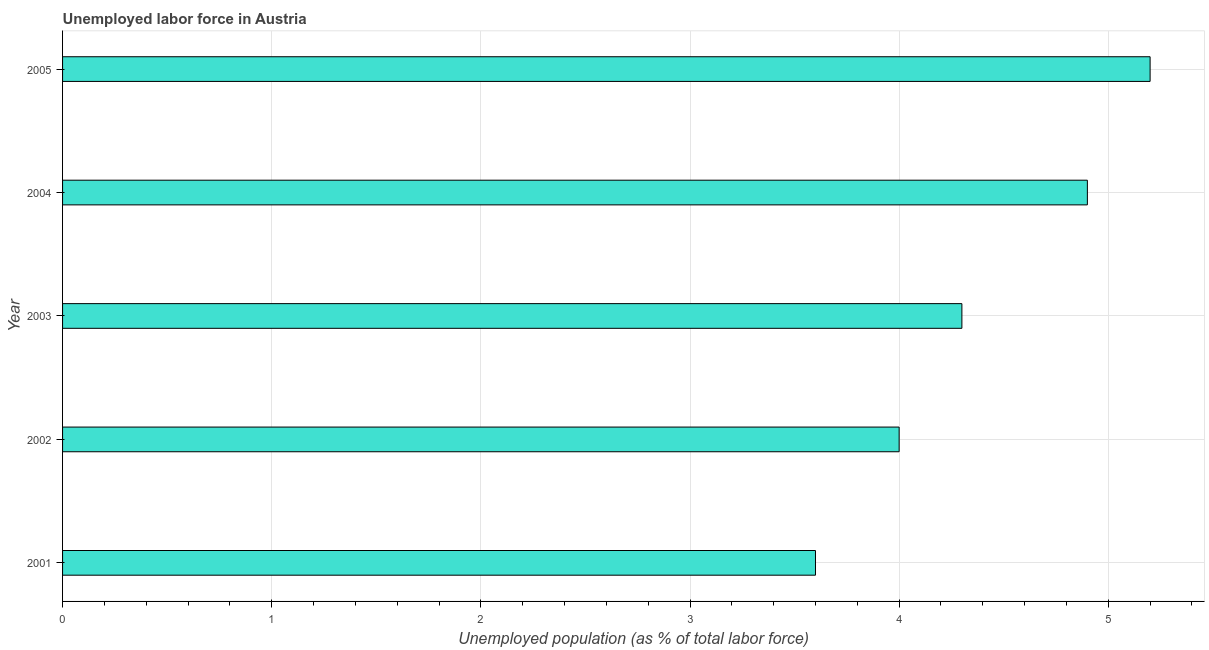What is the title of the graph?
Offer a very short reply. Unemployed labor force in Austria. What is the label or title of the X-axis?
Keep it short and to the point. Unemployed population (as % of total labor force). What is the label or title of the Y-axis?
Offer a terse response. Year. What is the total unemployed population in 2005?
Provide a succinct answer. 5.2. Across all years, what is the maximum total unemployed population?
Keep it short and to the point. 5.2. Across all years, what is the minimum total unemployed population?
Ensure brevity in your answer.  3.6. In which year was the total unemployed population minimum?
Your answer should be compact. 2001. What is the sum of the total unemployed population?
Your answer should be compact. 22. What is the difference between the total unemployed population in 2003 and 2004?
Make the answer very short. -0.6. What is the median total unemployed population?
Ensure brevity in your answer.  4.3. In how many years, is the total unemployed population greater than 1.8 %?
Your response must be concise. 5. What is the ratio of the total unemployed population in 2001 to that in 2004?
Your answer should be very brief. 0.73. Is the total unemployed population in 2001 less than that in 2004?
Provide a succinct answer. Yes. What is the difference between the highest and the second highest total unemployed population?
Offer a very short reply. 0.3. How many years are there in the graph?
Make the answer very short. 5. What is the Unemployed population (as % of total labor force) of 2001?
Provide a succinct answer. 3.6. What is the Unemployed population (as % of total labor force) in 2003?
Your answer should be compact. 4.3. What is the Unemployed population (as % of total labor force) of 2004?
Your answer should be very brief. 4.9. What is the Unemployed population (as % of total labor force) in 2005?
Ensure brevity in your answer.  5.2. What is the difference between the Unemployed population (as % of total labor force) in 2001 and 2002?
Offer a terse response. -0.4. What is the difference between the Unemployed population (as % of total labor force) in 2001 and 2003?
Make the answer very short. -0.7. What is the difference between the Unemployed population (as % of total labor force) in 2001 and 2004?
Provide a short and direct response. -1.3. What is the difference between the Unemployed population (as % of total labor force) in 2001 and 2005?
Make the answer very short. -1.6. What is the difference between the Unemployed population (as % of total labor force) in 2002 and 2004?
Offer a very short reply. -0.9. What is the difference between the Unemployed population (as % of total labor force) in 2003 and 2004?
Make the answer very short. -0.6. What is the ratio of the Unemployed population (as % of total labor force) in 2001 to that in 2003?
Your answer should be compact. 0.84. What is the ratio of the Unemployed population (as % of total labor force) in 2001 to that in 2004?
Provide a short and direct response. 0.73. What is the ratio of the Unemployed population (as % of total labor force) in 2001 to that in 2005?
Your response must be concise. 0.69. What is the ratio of the Unemployed population (as % of total labor force) in 2002 to that in 2003?
Provide a short and direct response. 0.93. What is the ratio of the Unemployed population (as % of total labor force) in 2002 to that in 2004?
Your answer should be compact. 0.82. What is the ratio of the Unemployed population (as % of total labor force) in 2002 to that in 2005?
Your answer should be very brief. 0.77. What is the ratio of the Unemployed population (as % of total labor force) in 2003 to that in 2004?
Your answer should be compact. 0.88. What is the ratio of the Unemployed population (as % of total labor force) in 2003 to that in 2005?
Make the answer very short. 0.83. What is the ratio of the Unemployed population (as % of total labor force) in 2004 to that in 2005?
Offer a terse response. 0.94. 